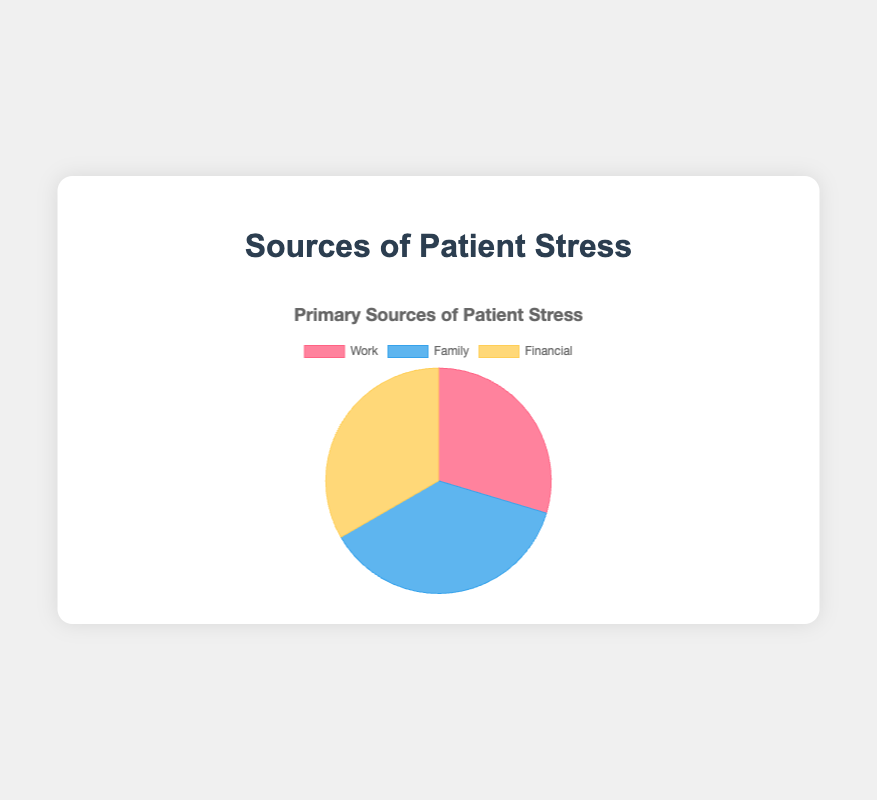What are the main sources of patient stress according to the pie chart? The pie chart shows three main sources of patient stress represented by different colors: Work, Family, and Financial, all with associated percentages. Each source segment indicates their relative contribution to patient stress.
Answer: Work, Family, Financial Which source of stress has the highest percentage? The pie chart segments indicate the percentages of stress sources, and the Family segment is represented with the largest size and a percentage value of 50%, higher than Work (40%) and Financial (45%).
Answer: Family Compare the percentages of the Family and Financial stress sources. Which one is higher? By observing the pie chart, the Family segment is marked with 50%, while the Financial segment is marked with 45%. Between the two, Family has a higher percentage.
Answer: Family What is the percentage difference between Work and Financial as sources of stress? From the pie chart, Work has a percentage of 40%, and Financial has a percentage of 45%. The difference in their percentages can be calculated as 45% - 40% = 5%.
Answer: 5% What three causes of stress contribute to the Work category, and what are their percentages? The pie chart and accompanying data description indicate three causes within the Work category: Long Working Hours (40%), High Job Demands (35%), and Job Insecurity (25%). Each segment detail provides the specific percentage contribution.
Answer: Long Working Hours (40%), High Job Demands (35%), Job Insecurity (25%) If you sum the percentages of all stress causes from the Work source, what total do you get? By adding the percentages associated with Long Working Hours, High Job Demands, and Job Insecurity from the Work category: 40% + 35% + 25% = 100%. This sum indicates the total contribution from each cause in the Work category.
Answer: 100% How is the Financial stress source visually distinguished from the others in terms of color? According to the pie chart and data provided, the Financial category is represented by a specific color which visually distinguishes it from other sources. Comparing to the other segments with different colors, the Financial segment is identified by its particular yellowish shade.
Answer: Yellow What’s the average percentage of stress causes under the Family category? The Family category includes Marital Conflict (50%), Caring for Children (30%), and Elderly Care (20%). The average percentage is calculated as (50% + 30% + 20%) / 3 = 33.33%. This represents the mean contribution of each cause to the Family stress category.
Answer: 33.33% Compare the contribution of Long Working Hours and Debt to their respective stress sources. Which is higher within their categories? For the Work category, Long Working Hours contributes 40%, while for the Financial category, Debt contributes 45%. Observing the percentages shows that Debt has a higher individual contribution within its category than Long Working Hours within its own.
Answer: Debt Which stress cause within the Financial category has the lowest percentage, and what is the percentage? According to the pie chart data, the Financial category includes Debt (45%), Saving for Future (35%), and Unexpected Expenses (20%). The lowest percentage within these is for Unexpected Expenses at 20%.
Answer: Unexpected Expenses (20%) 